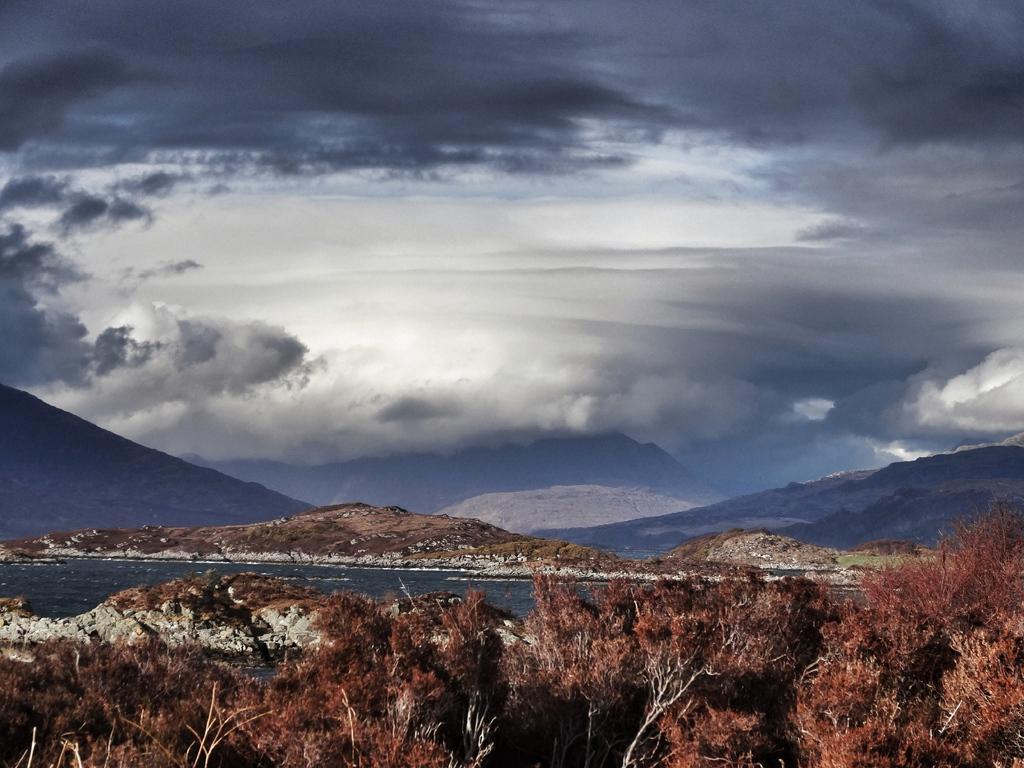Describe this image in one or two sentences. In this picture there are mountains and trees. At the top there are is sky and there are clouds. At the bottom there is water. 